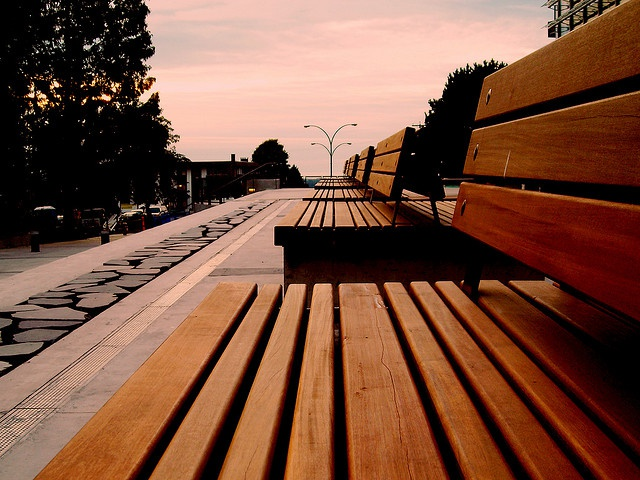Describe the objects in this image and their specific colors. I can see bench in black, maroon, brown, and tan tones, bench in black, red, tan, and maroon tones, bench in black, tan, and red tones, car in black, maroon, and gray tones, and bench in black, maroon, tan, and gray tones in this image. 